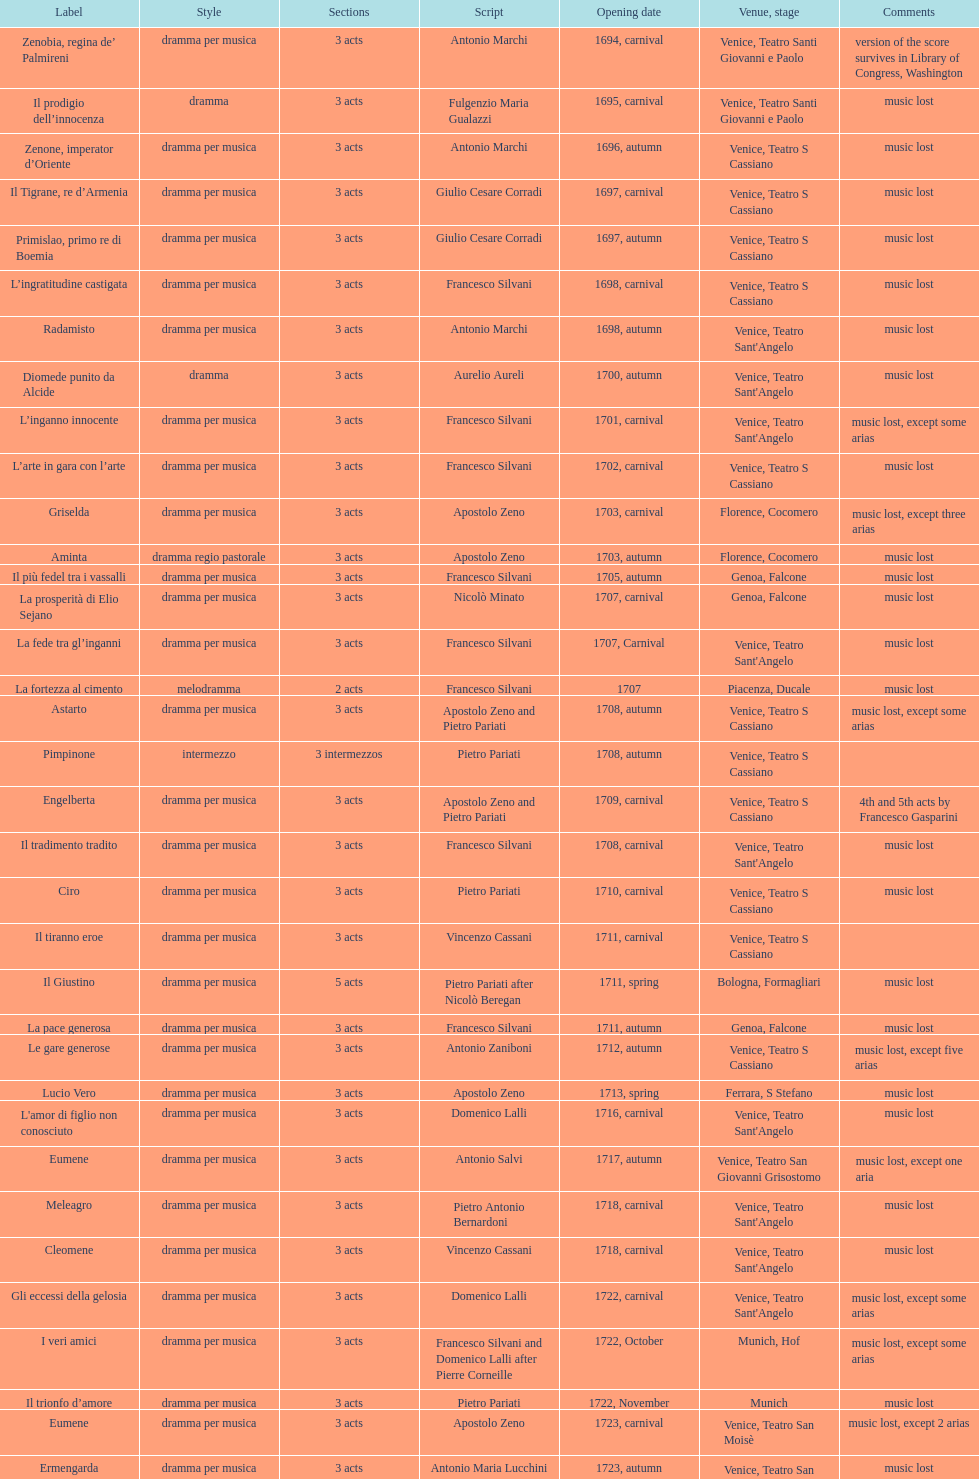Which title premiered directly after candalide? Artamene. 